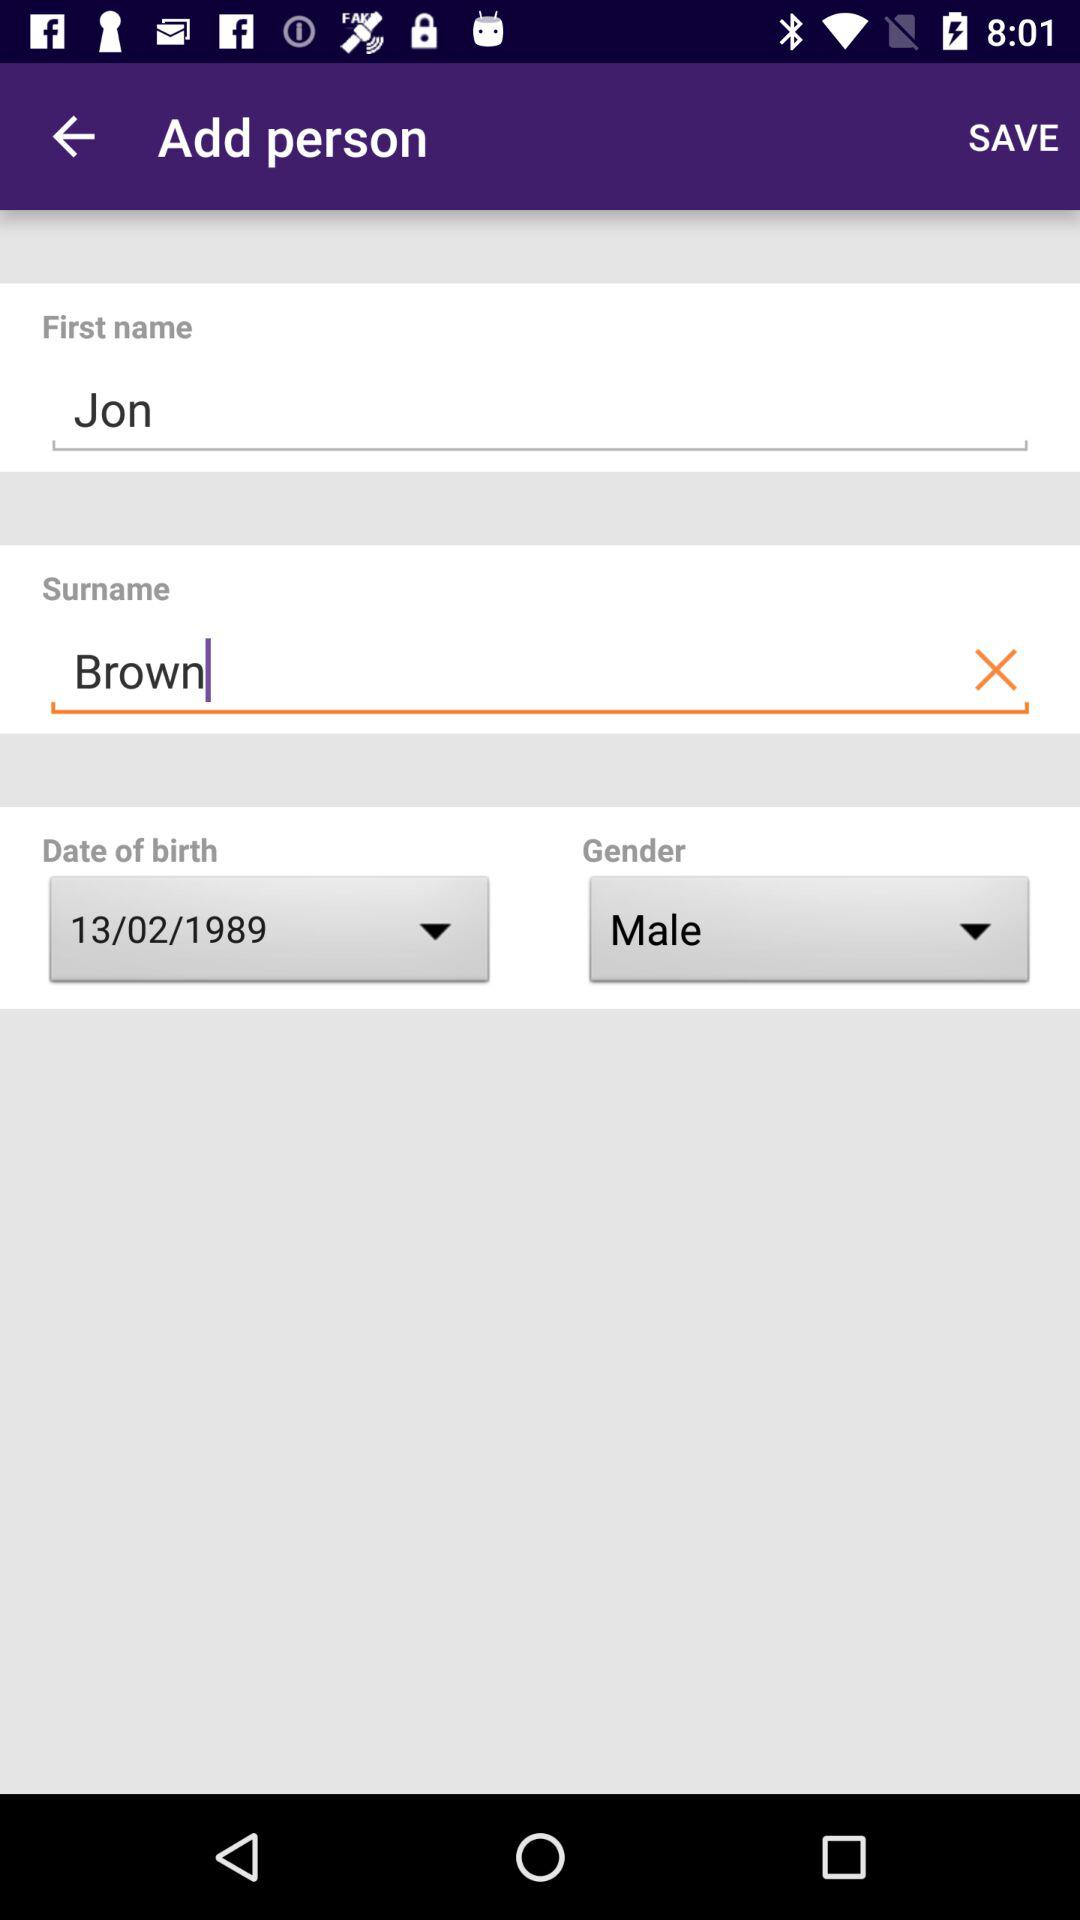What is the gender? The gender is male. 